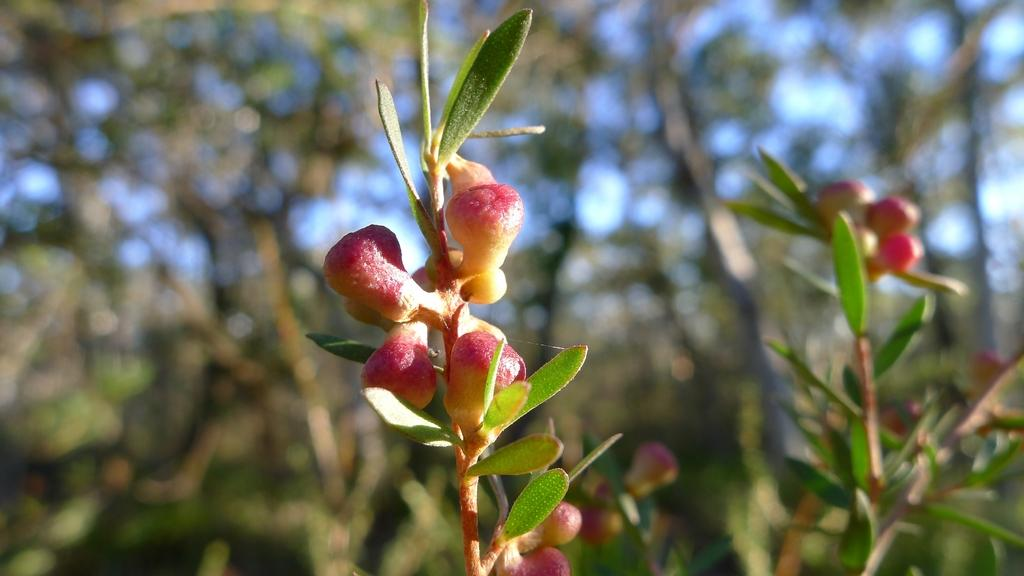What stage of growth are the plants in the image at? The plants in the image have buds, indicating they are in an early stage of growth. What type of vegetation can be seen in the background of the image? There are trees in the background of the image. What is visible in the sky in the image? The sky is visible in the background of the image. What riddle can be solved by looking at the plants in the image? There is no riddle present in the image, as it only features plants, trees, and the sky. Can you tell me how many ants are crawling on the plants in the image? There are no ants visible in the image; it only features plants, trees, and the sky. 